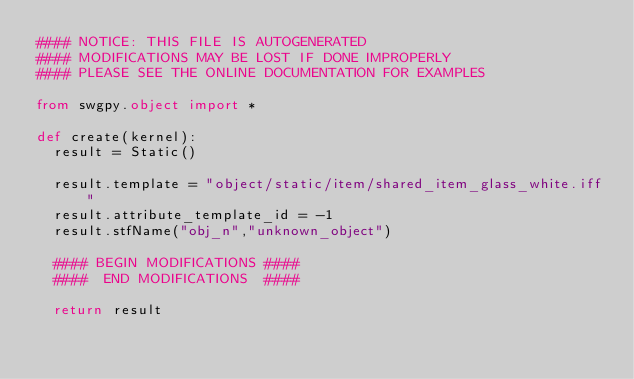<code> <loc_0><loc_0><loc_500><loc_500><_Python_>#### NOTICE: THIS FILE IS AUTOGENERATED
#### MODIFICATIONS MAY BE LOST IF DONE IMPROPERLY
#### PLEASE SEE THE ONLINE DOCUMENTATION FOR EXAMPLES

from swgpy.object import *	

def create(kernel):
	result = Static()

	result.template = "object/static/item/shared_item_glass_white.iff"
	result.attribute_template_id = -1
	result.stfName("obj_n","unknown_object")		
	
	#### BEGIN MODIFICATIONS ####
	####  END MODIFICATIONS  ####
	
	return result</code> 